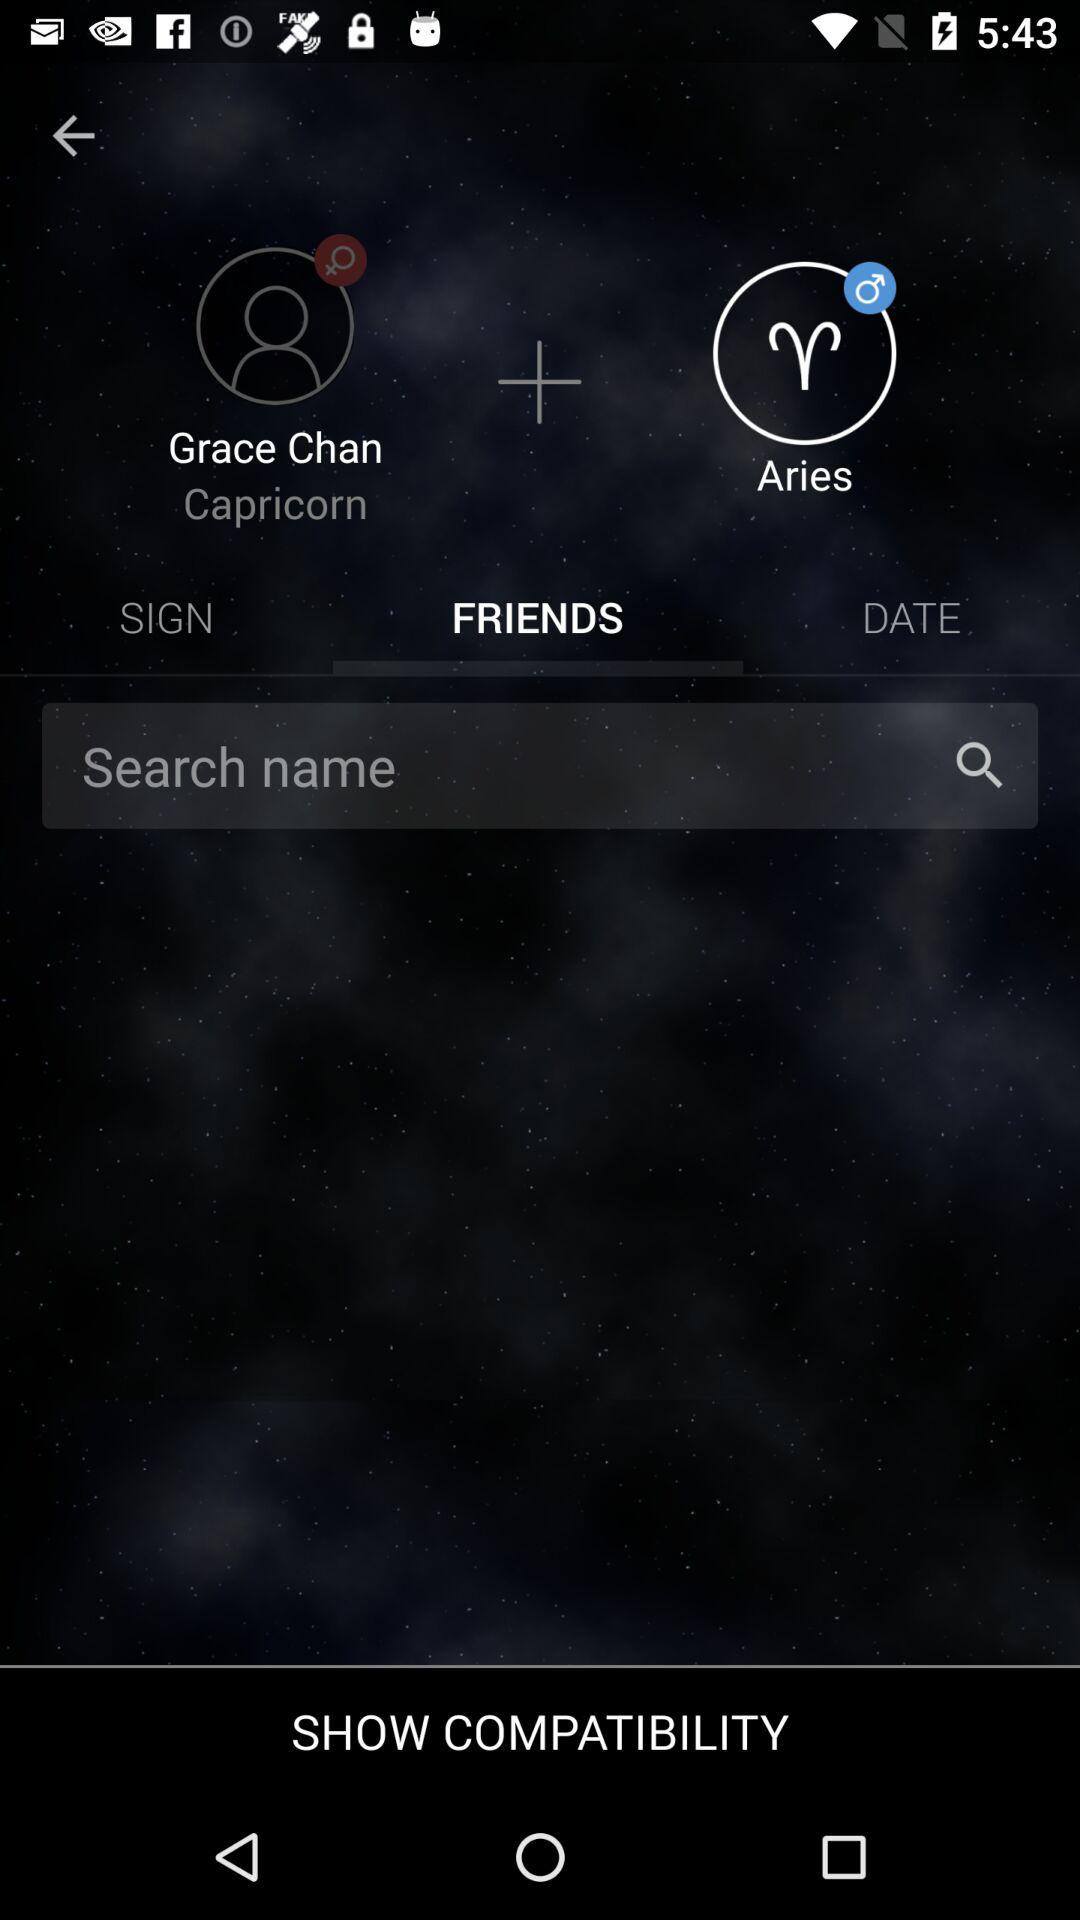What is the name of the user? The name of the user is Grace Chan. 